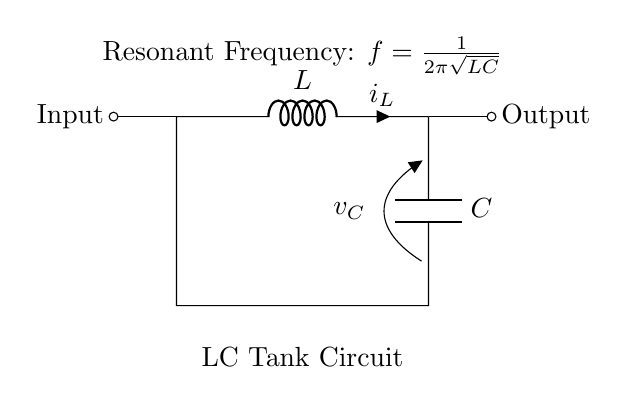What are the components in this circuit? The components visible in this circuit are an inductor (L) and a capacitor (C). These are standard components in an LC tank circuit used for tuning in applications like car stereos.
Answer: Inductor and Capacitor What is the symbol for the inductor? The circuit diagram shows a series of loops that represent the inductor component. This is its standard representation in circuit diagrams.
Answer: L What is the voltage across the capacitor? The circuit indicates that the voltage across the capacitor is labeled as v_C. This means it is denoted explicitly in the diagram for clarity.
Answer: v_C What is the resonant frequency equation provided in the diagram? The resonant frequency equation in the diagram is listed as f = 1/2π√(LC). This shows how the frequency relates to the values of L and C.
Answer: f = 1/2π√(LC) What type of circuit is depicted? The circuit depicted is called an LC tank circuit, which consists of an inductor and a capacitor that resonate at a specific frequency. This type of circuit is commonly used for tuning purposes in radio frequency applications.
Answer: LC Tank Circuit Why are inductors and capacitors used in this circuit? Inductors and capacitors are used because they store energy in electric and magnetic fields, respectively. When combined, they create resonant circuits capable of tuning to specific frequencies, which is essential in radio frequency applications.
Answer: Energy storage 